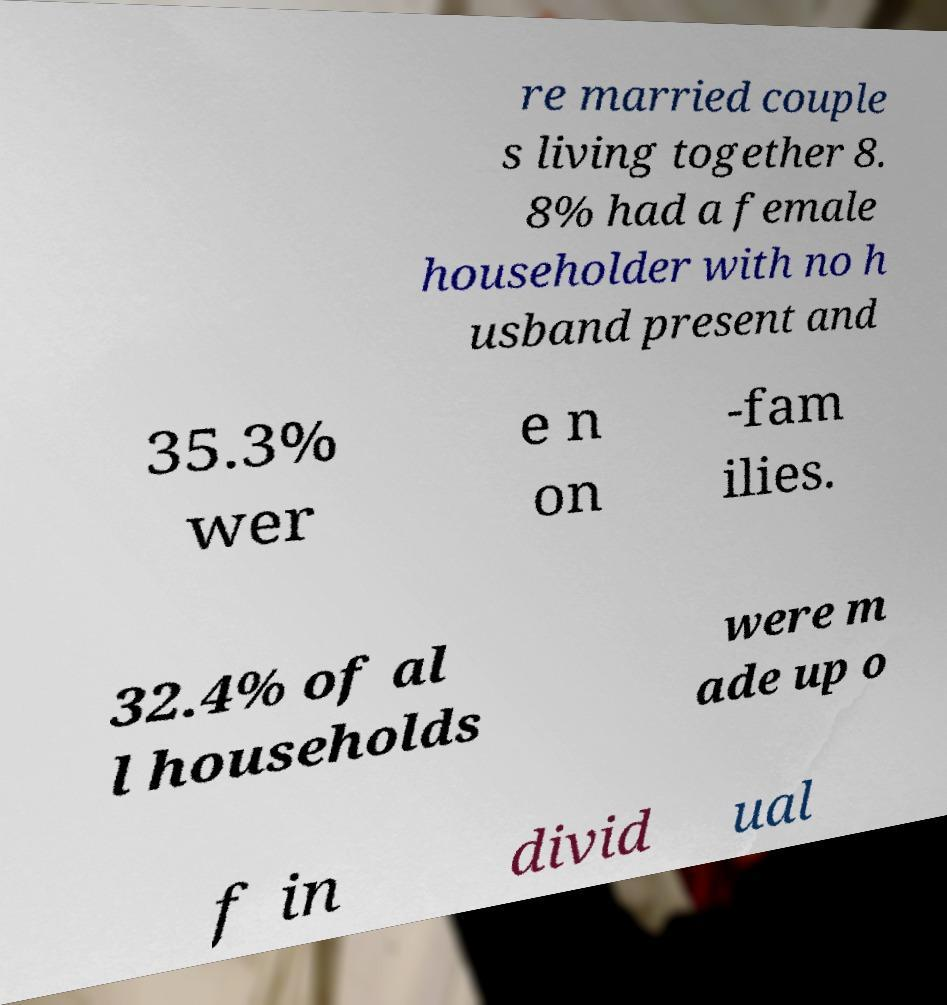Can you accurately transcribe the text from the provided image for me? re married couple s living together 8. 8% had a female householder with no h usband present and 35.3% wer e n on -fam ilies. 32.4% of al l households were m ade up o f in divid ual 